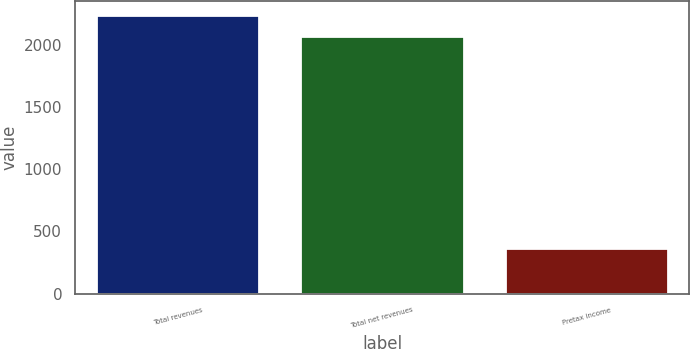Convert chart to OTSL. <chart><loc_0><loc_0><loc_500><loc_500><bar_chart><fcel>Total revenues<fcel>Total net revenues<fcel>Pretax income<nl><fcel>2242.3<fcel>2072<fcel>370<nl></chart> 